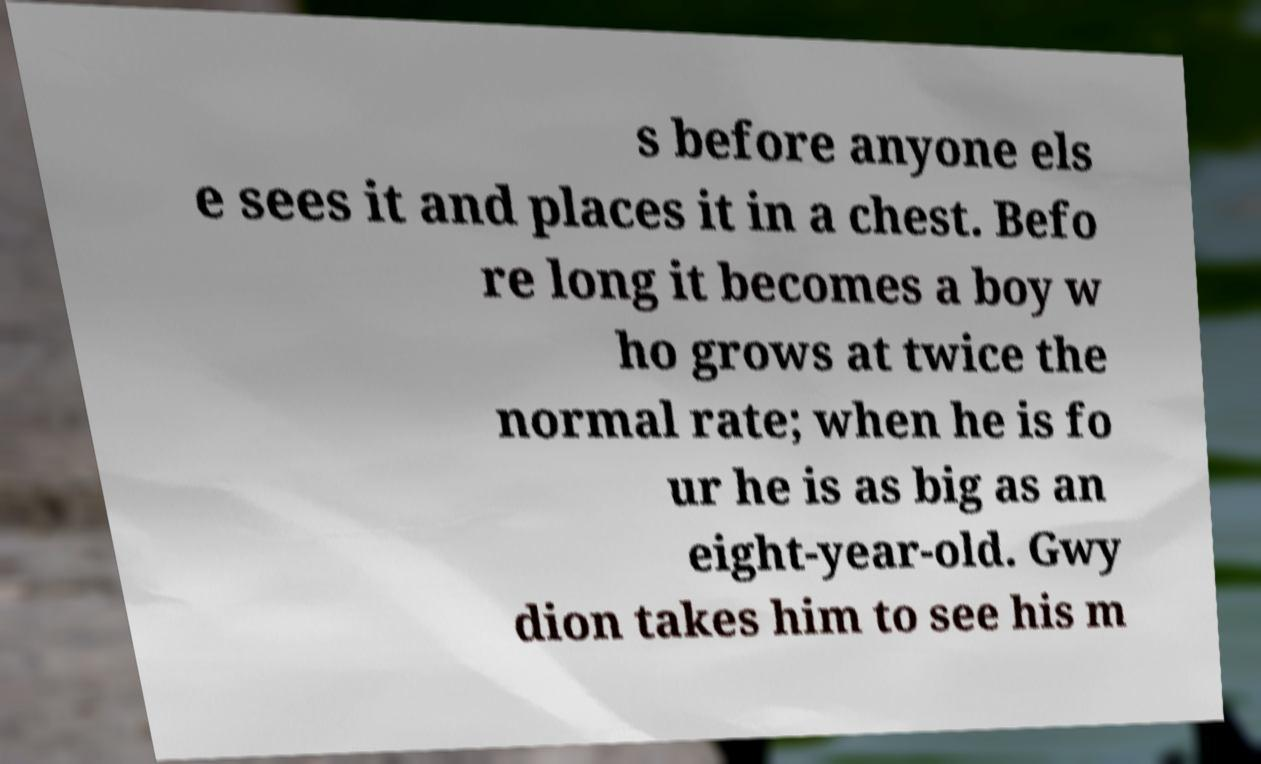I need the written content from this picture converted into text. Can you do that? s before anyone els e sees it and places it in a chest. Befo re long it becomes a boy w ho grows at twice the normal rate; when he is fo ur he is as big as an eight-year-old. Gwy dion takes him to see his m 